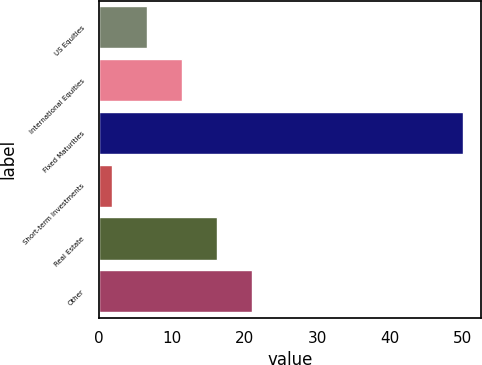Convert chart to OTSL. <chart><loc_0><loc_0><loc_500><loc_500><bar_chart><fcel>US Equities<fcel>International Equities<fcel>Fixed Maturities<fcel>Short-term Investments<fcel>Real Estate<fcel>Other<nl><fcel>6.66<fcel>11.48<fcel>50<fcel>1.84<fcel>16.3<fcel>21.12<nl></chart> 